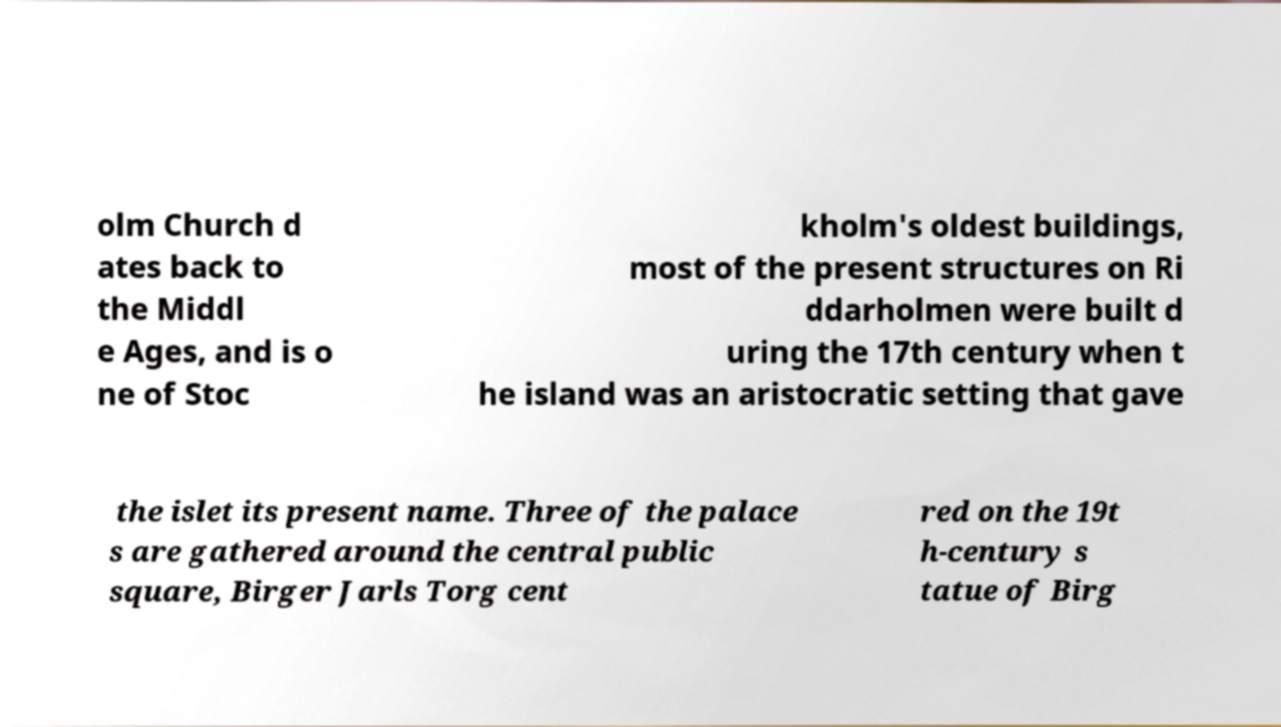I need the written content from this picture converted into text. Can you do that? olm Church d ates back to the Middl e Ages, and is o ne of Stoc kholm's oldest buildings, most of the present structures on Ri ddarholmen were built d uring the 17th century when t he island was an aristocratic setting that gave the islet its present name. Three of the palace s are gathered around the central public square, Birger Jarls Torg cent red on the 19t h-century s tatue of Birg 